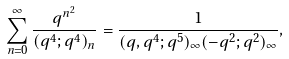Convert formula to latex. <formula><loc_0><loc_0><loc_500><loc_500>\sum _ { n = 0 } ^ { \infty } \frac { q ^ { n ^ { 2 } } } { ( q ^ { 4 } ; q ^ { 4 } ) _ { n } } = \frac { 1 } { ( q , q ^ { 4 } ; q ^ { 5 } ) _ { \infty } ( - q ^ { 2 } ; q ^ { 2 } ) _ { \infty } } ,</formula> 